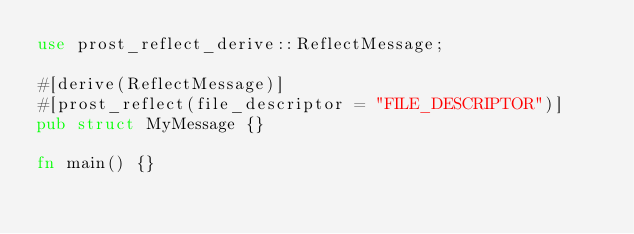Convert code to text. <code><loc_0><loc_0><loc_500><loc_500><_Rust_>use prost_reflect_derive::ReflectMessage;

#[derive(ReflectMessage)]
#[prost_reflect(file_descriptor = "FILE_DESCRIPTOR")]
pub struct MyMessage {}

fn main() {}
</code> 